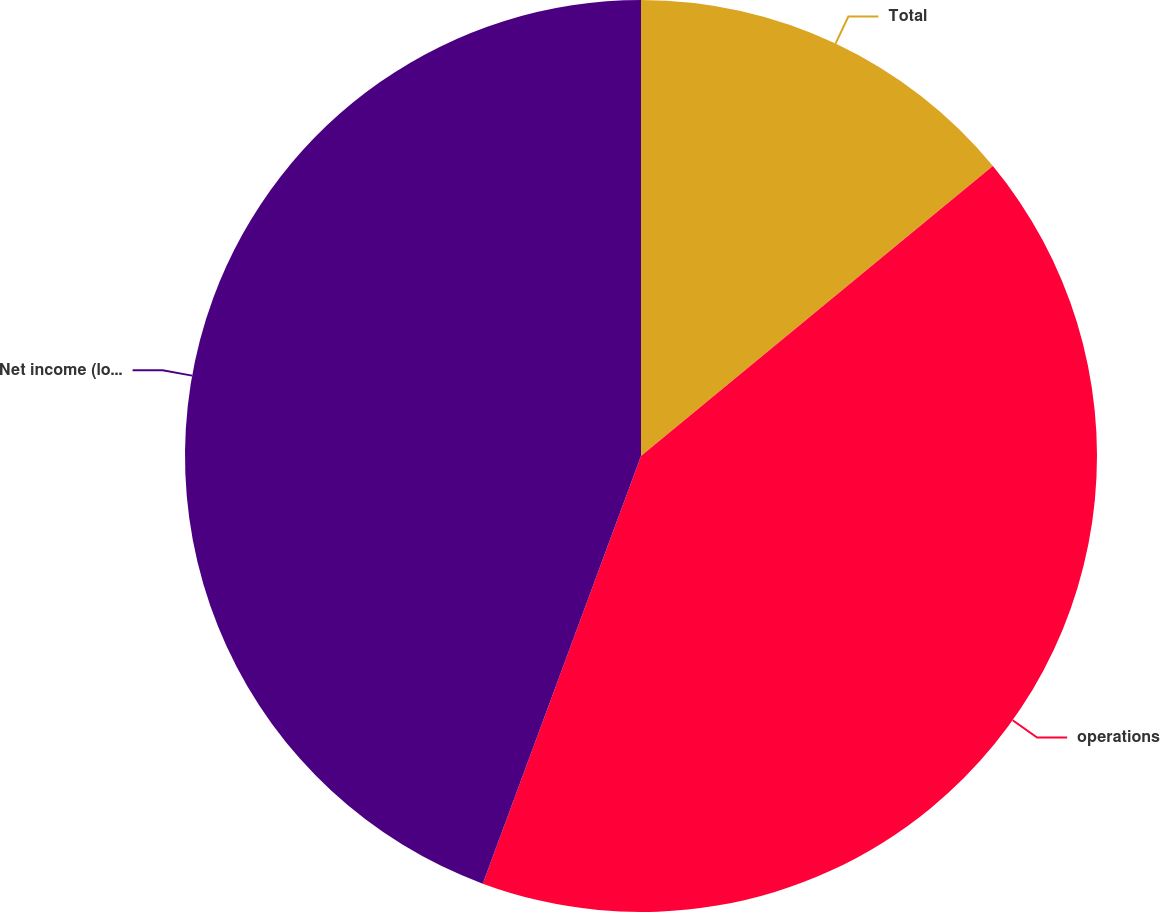Convert chart. <chart><loc_0><loc_0><loc_500><loc_500><pie_chart><fcel>Total<fcel>operations<fcel>Net income (loss)<nl><fcel>14.03%<fcel>41.61%<fcel>44.36%<nl></chart> 